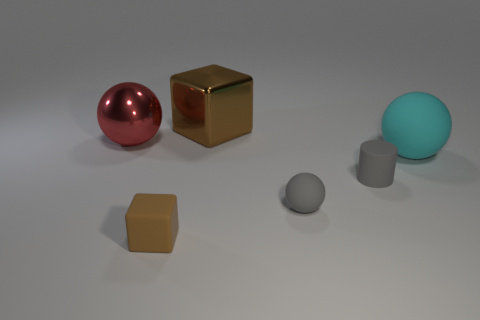Add 3 metal balls. How many objects exist? 9 Subtract all cubes. How many objects are left? 4 Subtract 0 red cylinders. How many objects are left? 6 Subtract all tiny blocks. Subtract all matte cubes. How many objects are left? 4 Add 5 brown metallic things. How many brown metallic things are left? 6 Add 1 large cyan metallic objects. How many large cyan metallic objects exist? 1 